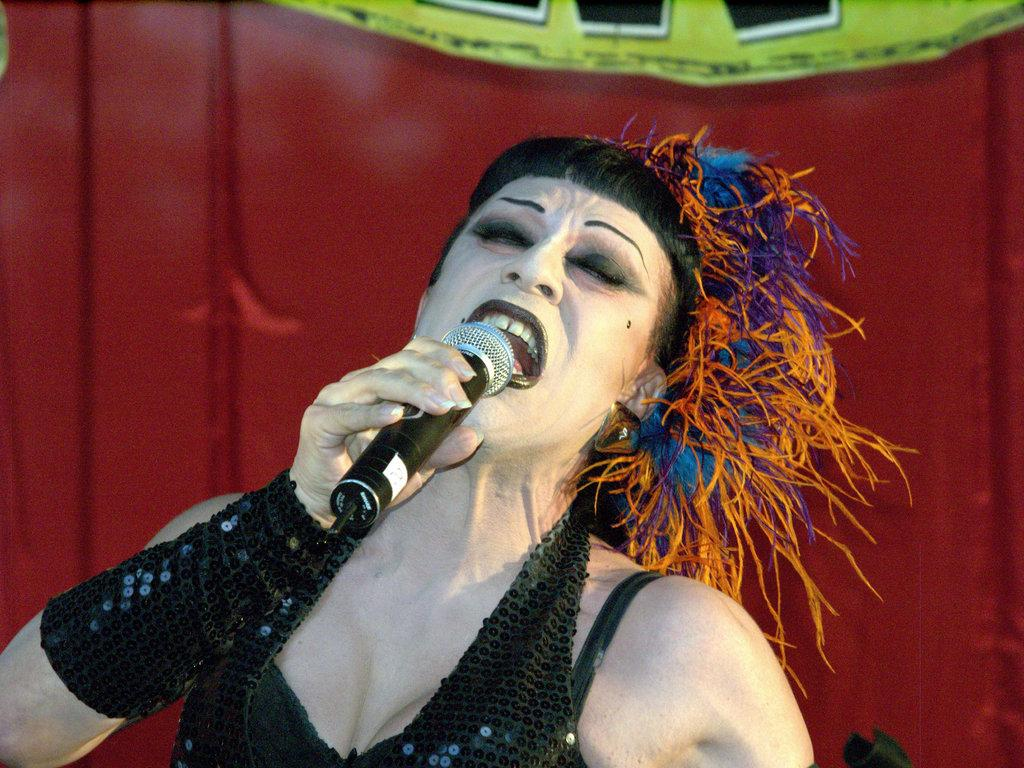Where was the image taken? The image was taken on a stage. What is the woman doing on the stage? The woman is singing on the stage. How is the woman singing? The woman is holding a microphone (mic) while singing. What color is the woman's eye in the image? The provided facts do not mention the color of the woman's eye, so it cannot be determined from the image. Is there a sofa visible in the image? There is no sofa present in the image; it is taken on a stage with a woman singing. 